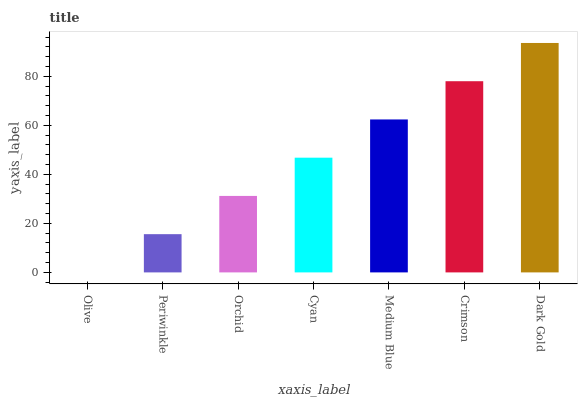Is Olive the minimum?
Answer yes or no. Yes. Is Dark Gold the maximum?
Answer yes or no. Yes. Is Periwinkle the minimum?
Answer yes or no. No. Is Periwinkle the maximum?
Answer yes or no. No. Is Periwinkle greater than Olive?
Answer yes or no. Yes. Is Olive less than Periwinkle?
Answer yes or no. Yes. Is Olive greater than Periwinkle?
Answer yes or no. No. Is Periwinkle less than Olive?
Answer yes or no. No. Is Cyan the high median?
Answer yes or no. Yes. Is Cyan the low median?
Answer yes or no. Yes. Is Dark Gold the high median?
Answer yes or no. No. Is Orchid the low median?
Answer yes or no. No. 